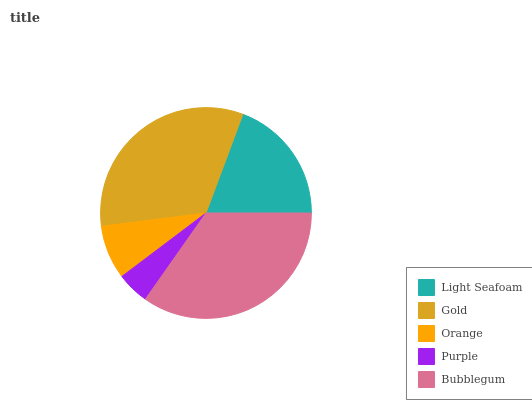Is Purple the minimum?
Answer yes or no. Yes. Is Bubblegum the maximum?
Answer yes or no. Yes. Is Gold the minimum?
Answer yes or no. No. Is Gold the maximum?
Answer yes or no. No. Is Gold greater than Light Seafoam?
Answer yes or no. Yes. Is Light Seafoam less than Gold?
Answer yes or no. Yes. Is Light Seafoam greater than Gold?
Answer yes or no. No. Is Gold less than Light Seafoam?
Answer yes or no. No. Is Light Seafoam the high median?
Answer yes or no. Yes. Is Light Seafoam the low median?
Answer yes or no. Yes. Is Purple the high median?
Answer yes or no. No. Is Purple the low median?
Answer yes or no. No. 